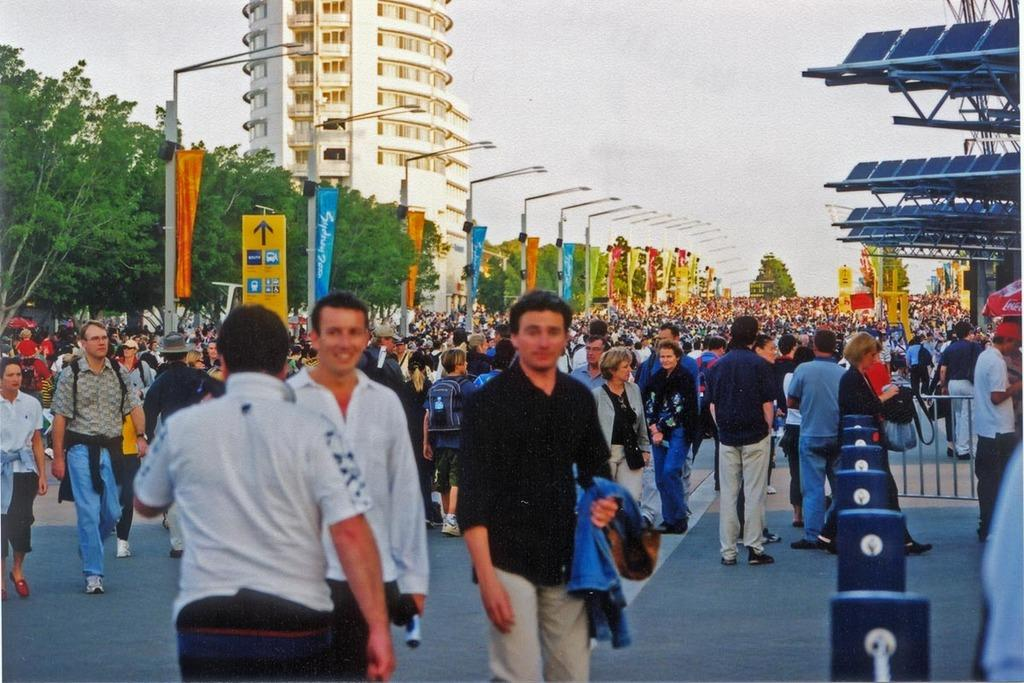What is the main subject of the image? There is a group of people on the ground in the image. What can be seen in the background of the image? In the background of the image, there is a fence, banners, poles, trees, a building, and the sky. There are also unspecified objects present. Can you describe the setting of the image? The image appears to be set outdoors, with a group of people gathered on the ground and various structures and natural elements visible in the background. How many eyes can be seen on the jelly in the image? There is no jelly present in the image, and therefore no eyes can be seen on it. What type of trade is being conducted in the image? There is no indication of any trade being conducted in the image; it primarily features a group of people and various background elements. 